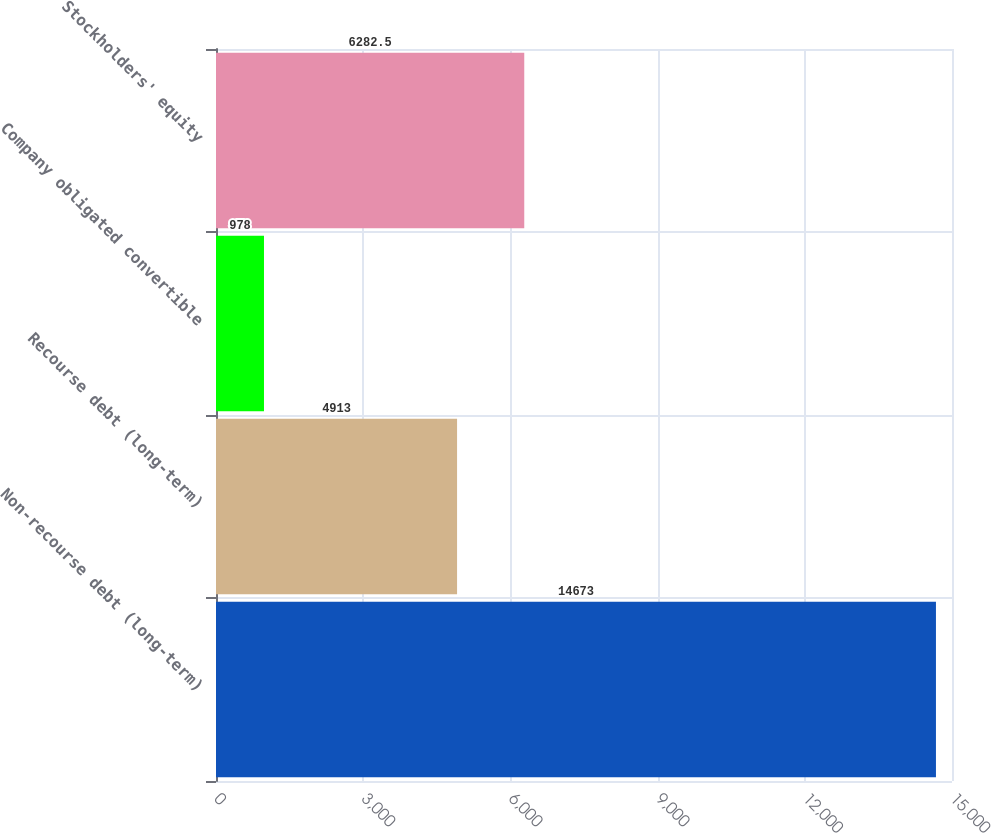<chart> <loc_0><loc_0><loc_500><loc_500><bar_chart><fcel>Non-recourse debt (long-term)<fcel>Recourse debt (long-term)<fcel>Company obligated convertible<fcel>Stockholders' equity<nl><fcel>14673<fcel>4913<fcel>978<fcel>6282.5<nl></chart> 